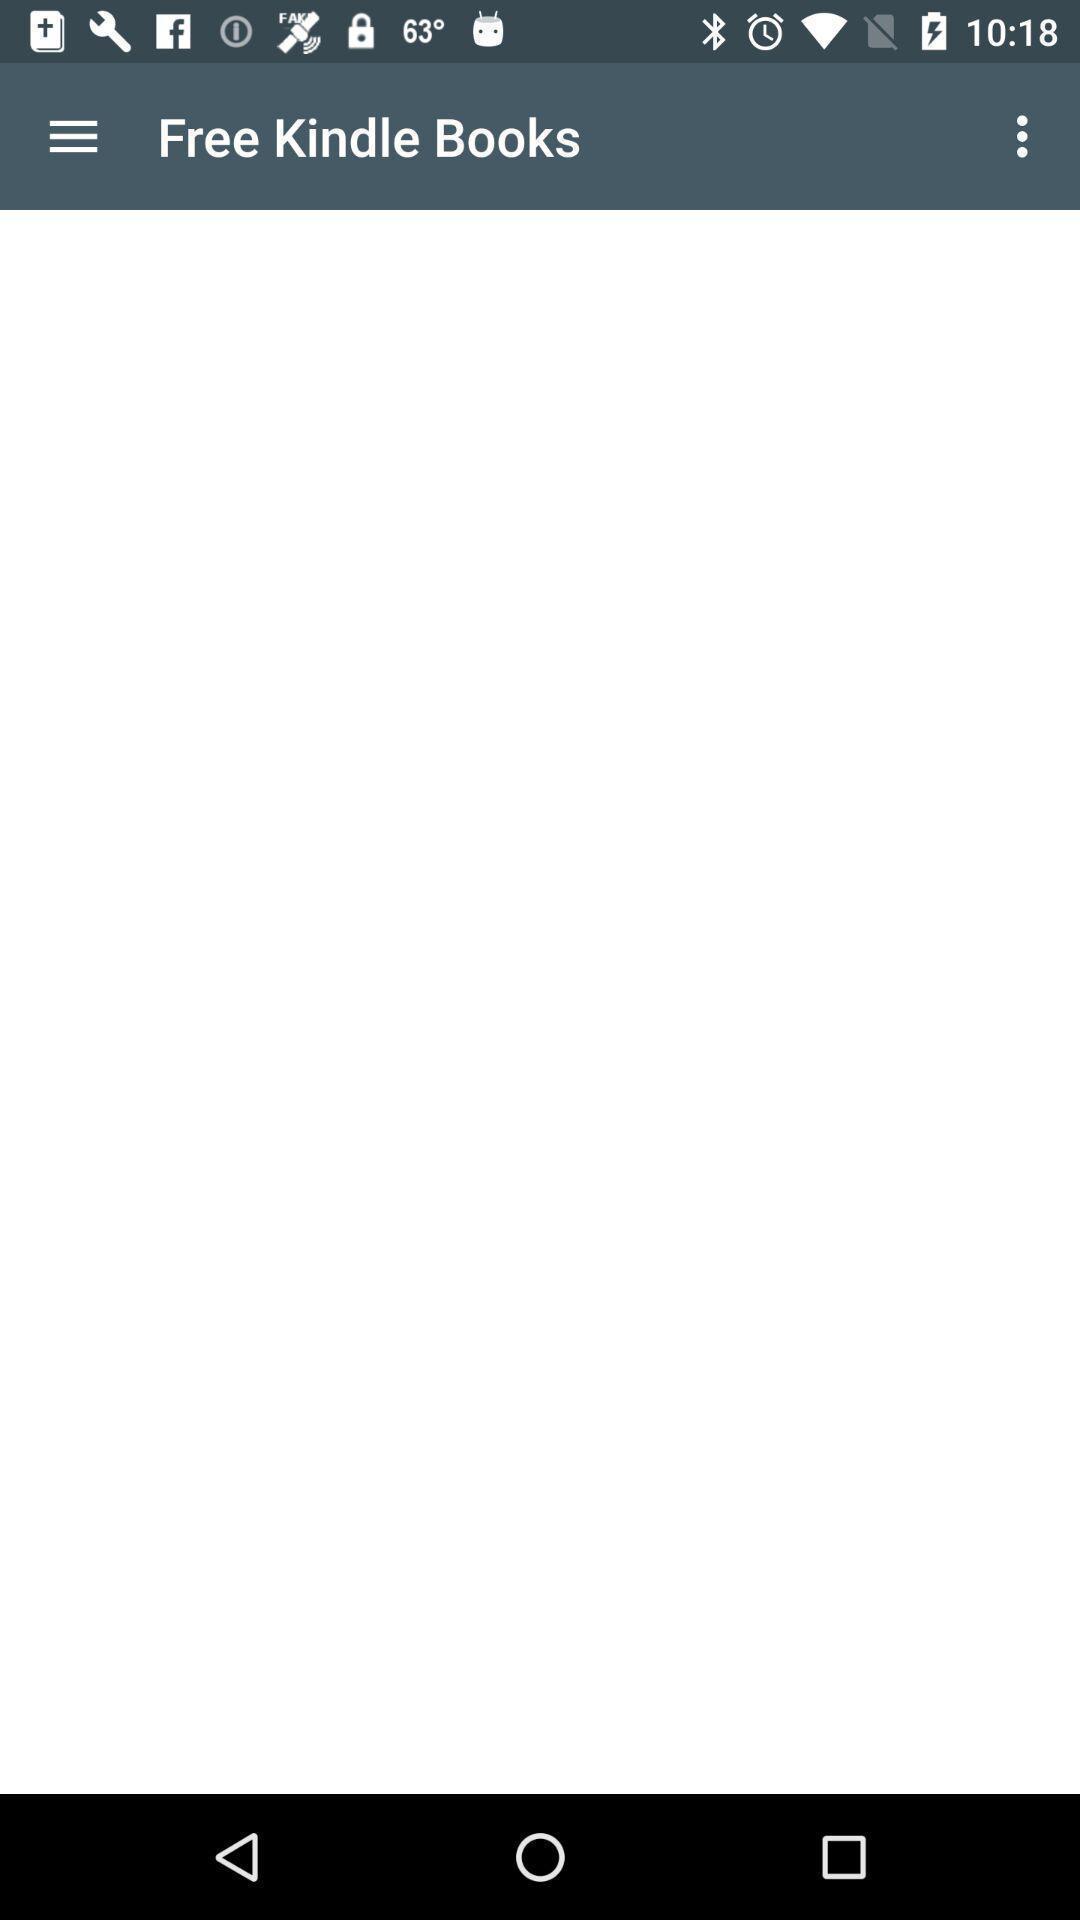Please provide a description for this image. Page showing free books with no content. 